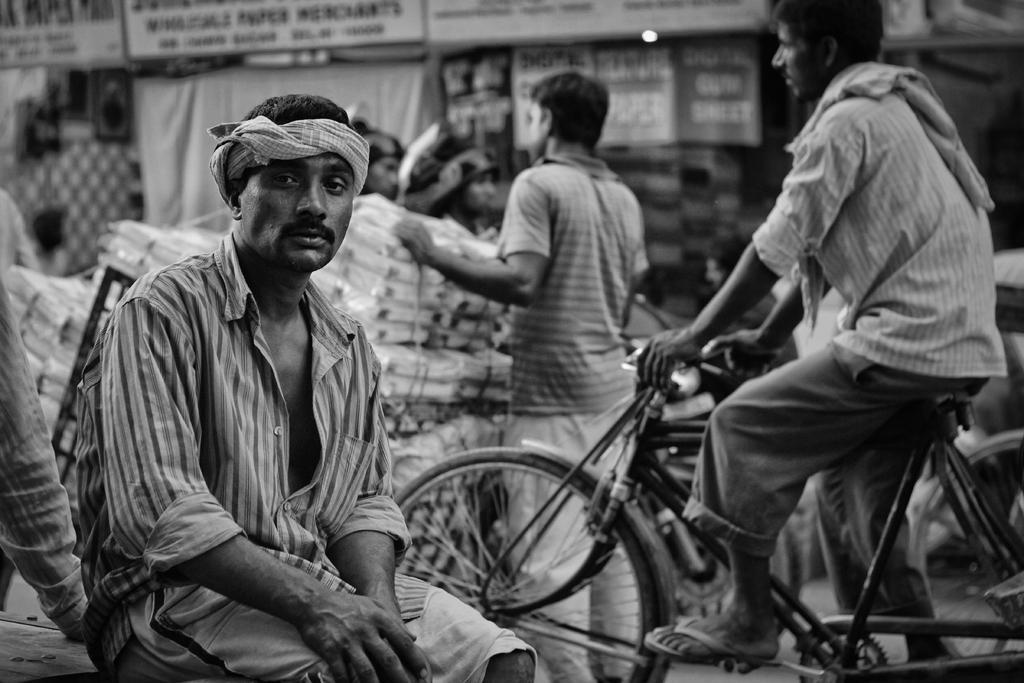Please provide a concise description of this image. A black and white picture. This person is sitting on a bench. This person is sitting on a bicycle. This person is standing and holding this things. These are boards. 